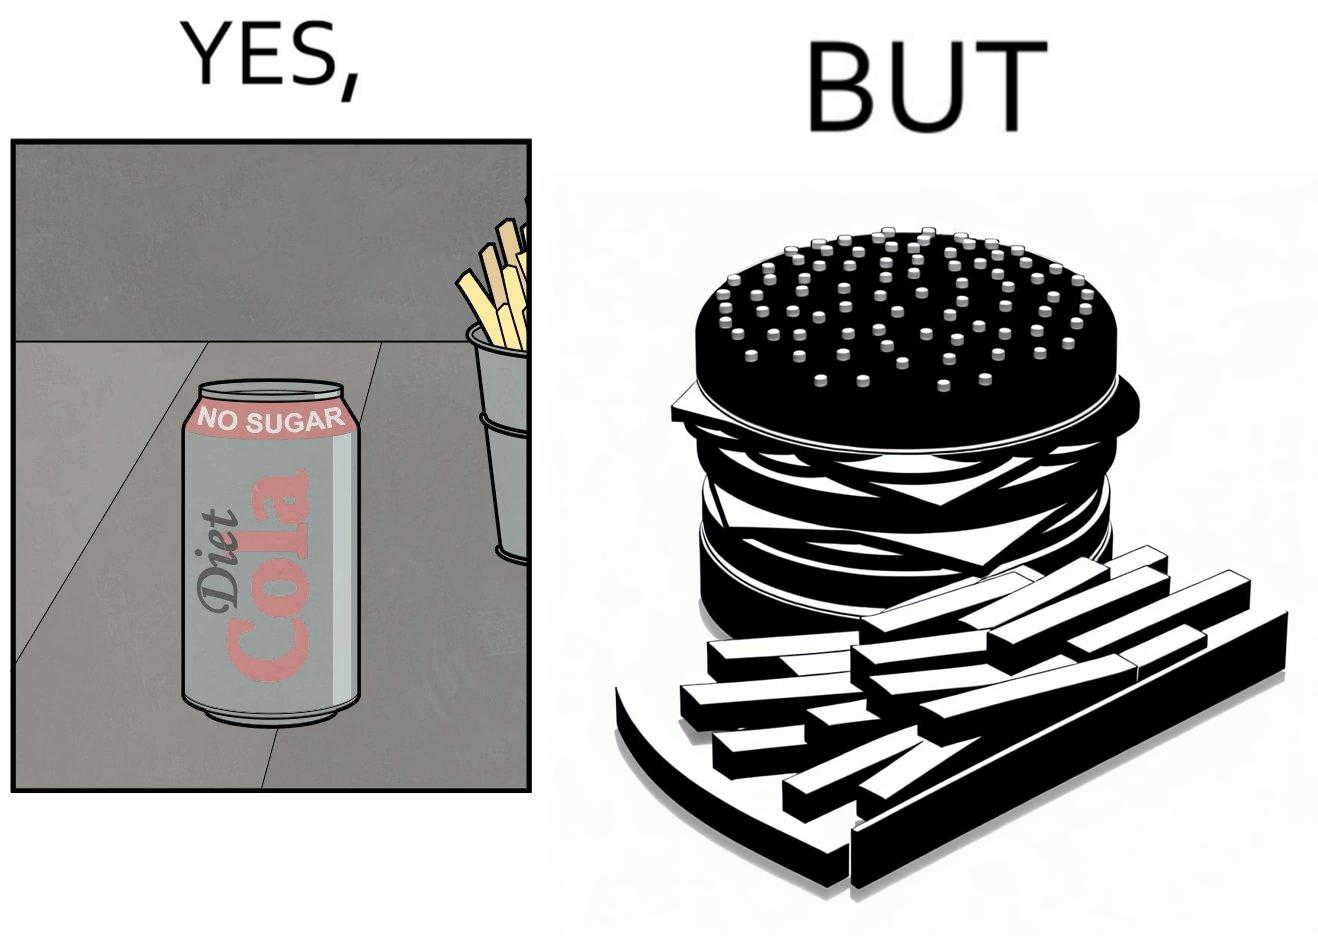Would you classify this image as satirical? Yes, this image is satirical. 